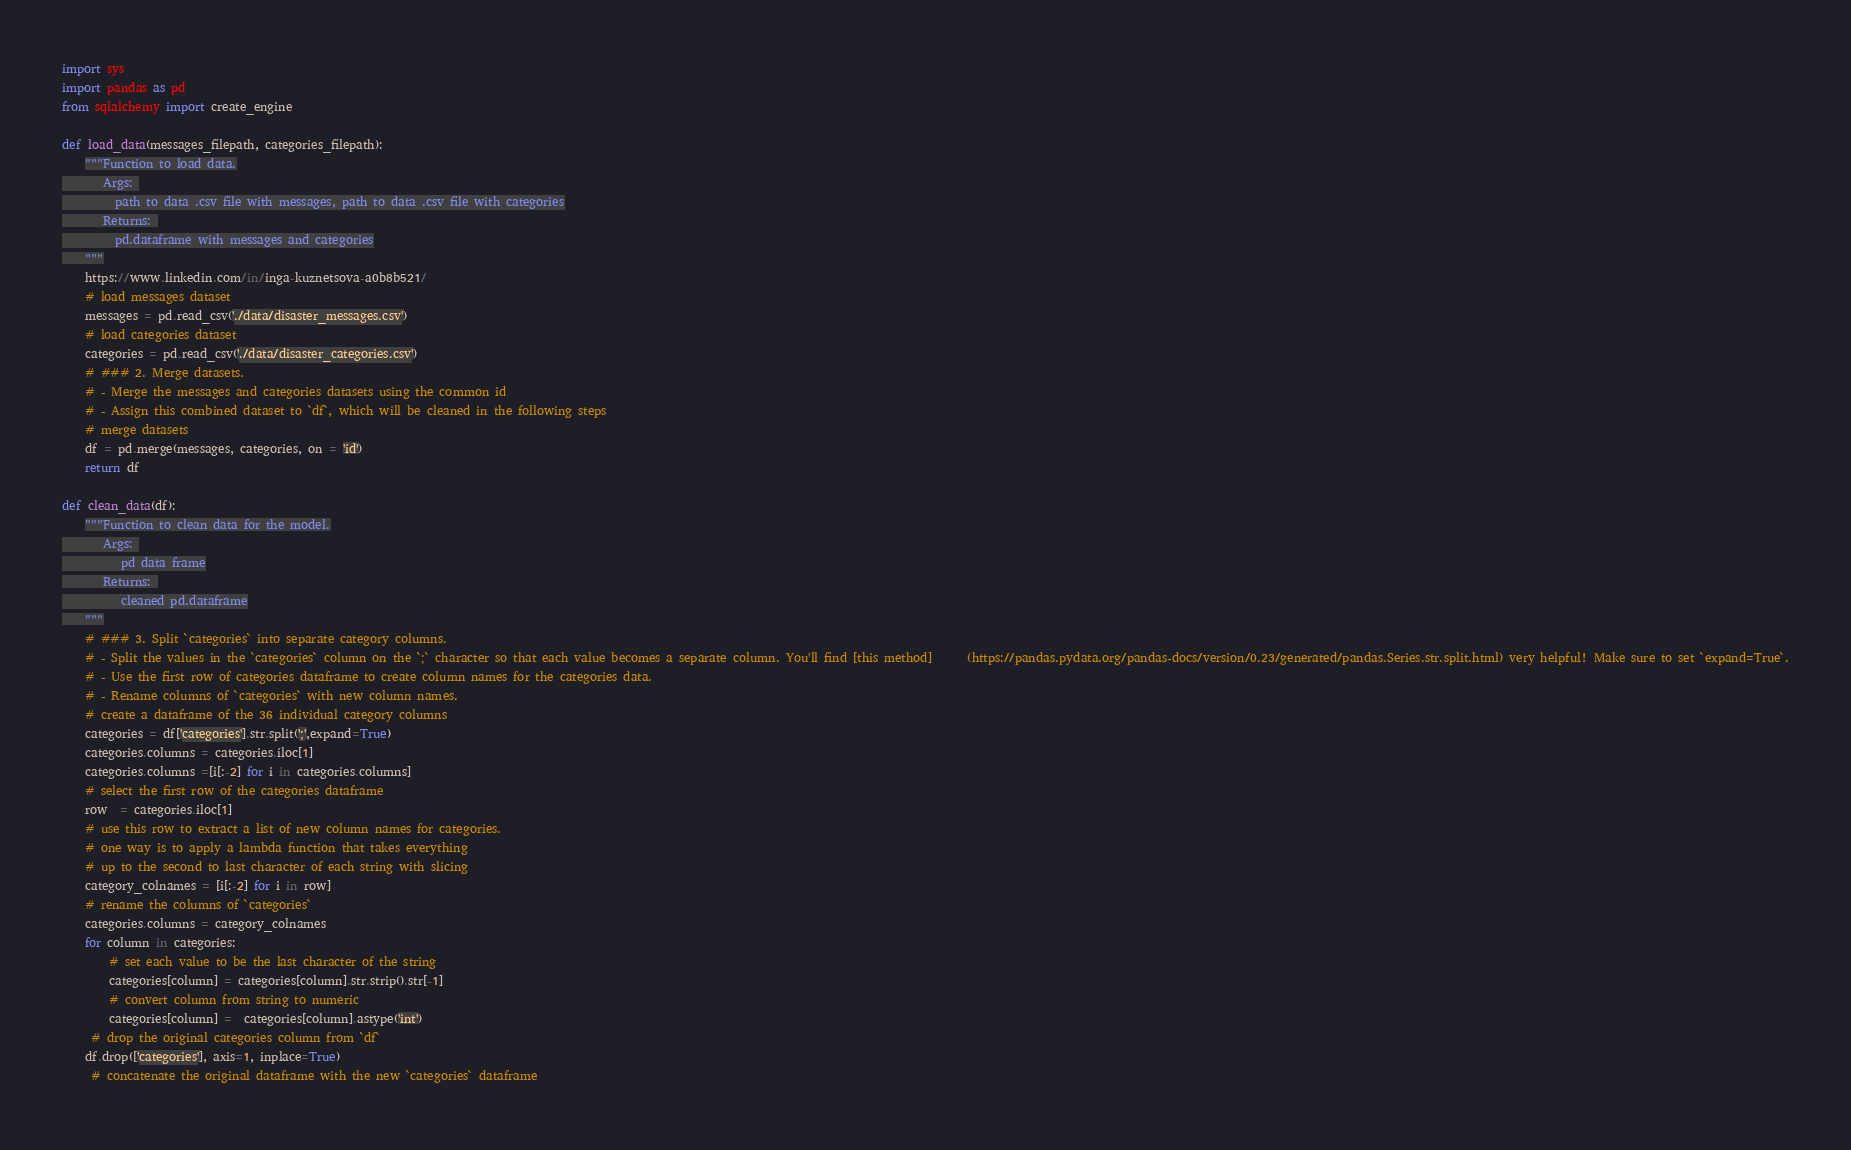<code> <loc_0><loc_0><loc_500><loc_500><_Python_>import sys
import pandas as pd
from sqlalchemy import create_engine

def load_data(messages_filepath, categories_filepath):
    """Function to load data.
       Args: 
         path to data .csv file with messages, path to data .csv file with categories
       Returns: 
         pd.dataframe with messages and categories
    """
    https://www.linkedin.com/in/inga-kuznetsova-a0b8b521/
    # load messages dataset
    messages = pd.read_csv('./data/disaster_messages.csv')
    # load categories dataset
    categories = pd.read_csv('./data/disaster_categories.csv')
    # ### 2. Merge datasets.
    # - Merge the messages and categories datasets using the common id
    # - Assign this combined dataset to `df`, which will be cleaned in the following steps
    # merge datasets
    df = pd.merge(messages, categories, on = 'id')
    return df

def clean_data(df):
    """Function to clean data for the model.
       Args: 
          pd data frame
       Returns: 
          cleaned pd.dataframe
    """
    # ### 3. Split `categories` into separate category columns.
    # - Split the values in the `categories` column on the `;` character so that each value becomes a separate column. You'll find [this method]      (https://pandas.pydata.org/pandas-docs/version/0.23/generated/pandas.Series.str.split.html) very helpful! Make sure to set `expand=True`.
    # - Use the first row of categories dataframe to create column names for the categories data.
    # - Rename columns of `categories` with new column names.
    # create a dataframe of the 36 individual category columns
    categories = df['categories'].str.split(';',expand=True)
    categories.columns = categories.iloc[1]
    categories.columns =[i[:-2] for i in categories.columns]
    # select the first row of the categories dataframe
    row  = categories.iloc[1]
    # use this row to extract a list of new column names for categories.
    # one way is to apply a lambda function that takes everything 
    # up to the second to last character of each string with slicing
    category_colnames = [i[:-2] for i in row]    
    # rename the columns of `categories`
    categories.columns = category_colnames
    for column in categories:
        # set each value to be the last character of the string
        categories[column] = categories[column].str.strip().str[-1] 
        # convert column from string to numeric
        categories[column] =  categories[column].astype('int')
     # drop the original categories column from `df`
    df.drop(['categories'], axis=1, inplace=True)
     # concatenate the original dataframe with the new `categories` dataframe</code> 